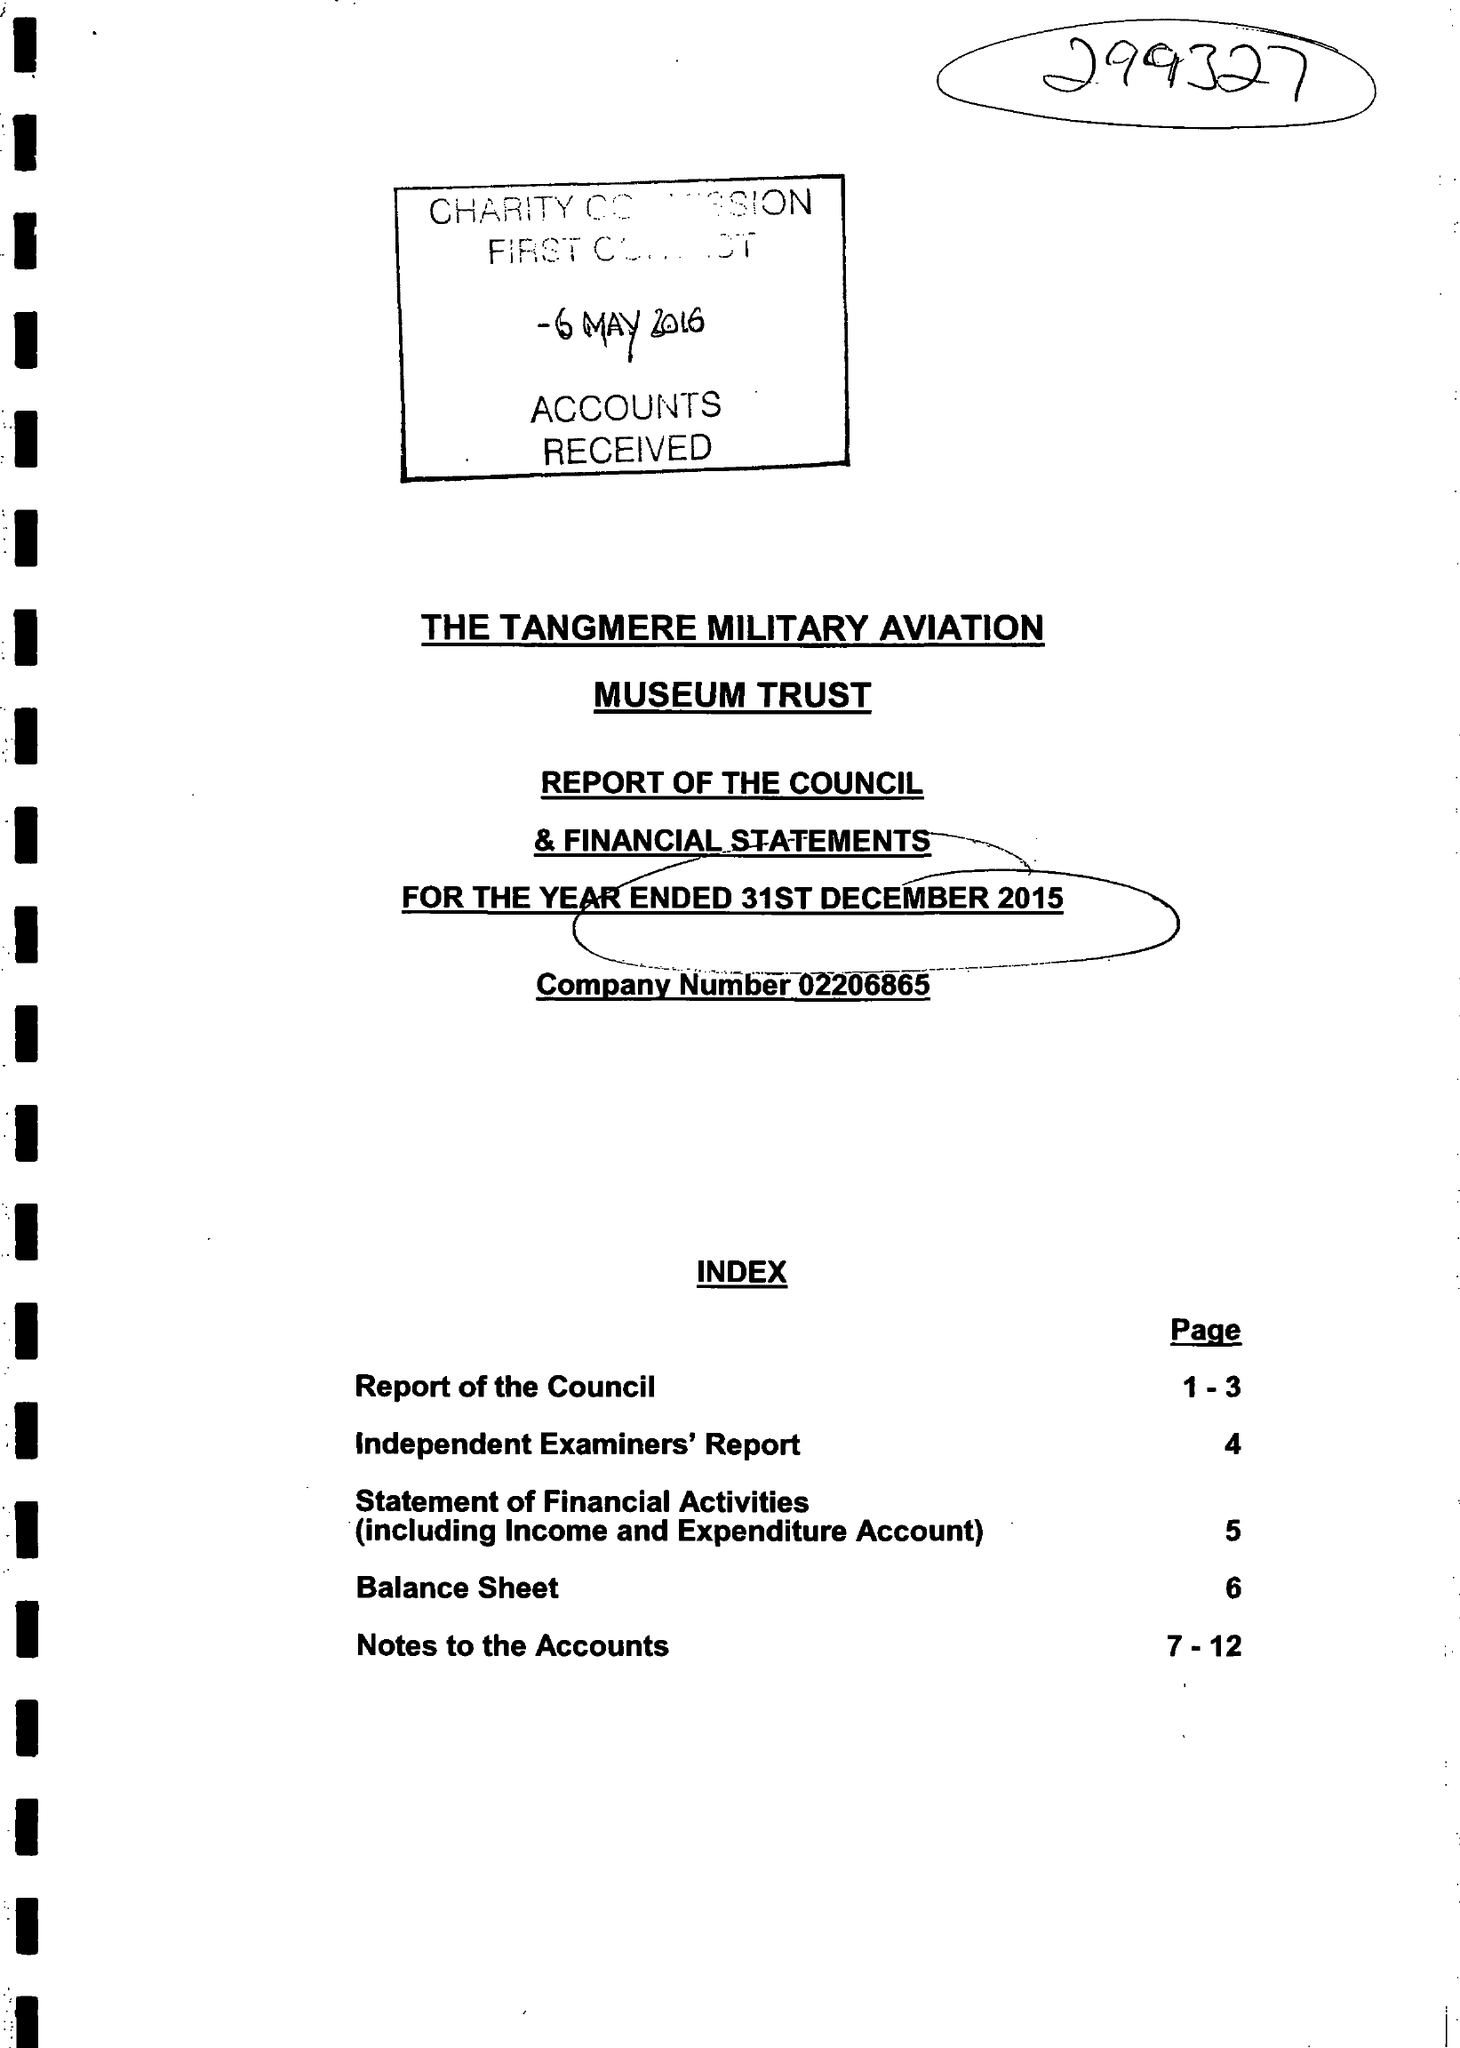What is the value for the charity_name?
Answer the question using a single word or phrase. The Tangmere Military Aviation Museum Trust 